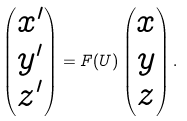Convert formula to latex. <formula><loc_0><loc_0><loc_500><loc_500>\begin{pmatrix} x ^ { \prime } \\ y ^ { \prime } \\ z ^ { \prime } \end{pmatrix} = F ( U ) \begin{pmatrix} x \\ y \\ z \end{pmatrix} .</formula> 